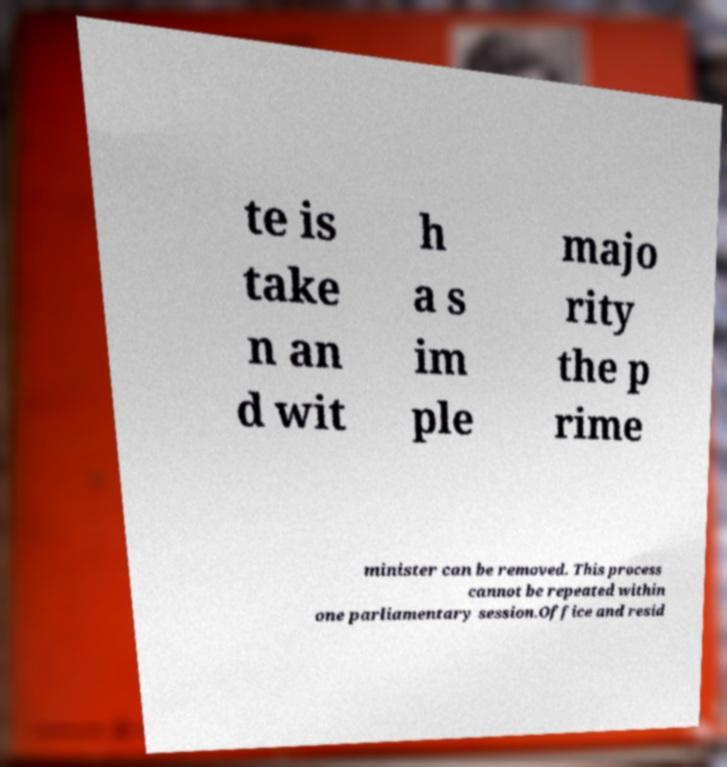For documentation purposes, I need the text within this image transcribed. Could you provide that? te is take n an d wit h a s im ple majo rity the p rime minister can be removed. This process cannot be repeated within one parliamentary session.Office and resid 